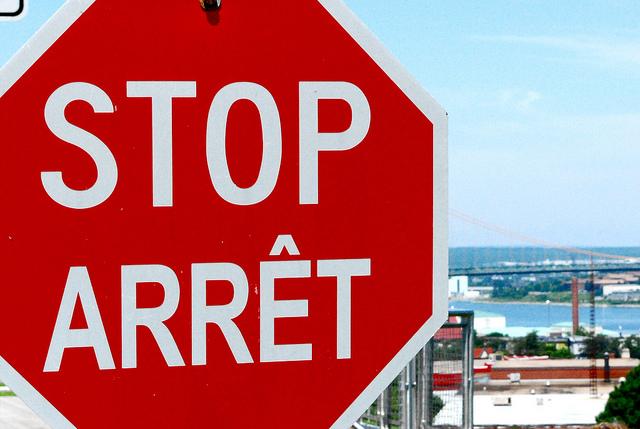How many languages are on the sign?
Be succinct. 2. Is there a bridge in the background?
Be succinct. Yes. In what city is this?
Concise answer only. France. What sign is this?
Answer briefly. Stop. 